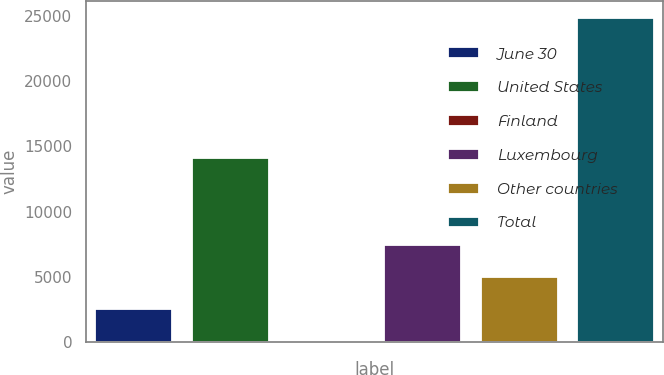<chart> <loc_0><loc_0><loc_500><loc_500><bar_chart><fcel>June 30<fcel>United States<fcel>Finland<fcel>Luxembourg<fcel>Other countries<fcel>Total<nl><fcel>2496.3<fcel>14081<fcel>8<fcel>7472.9<fcel>4984.6<fcel>24891<nl></chart> 